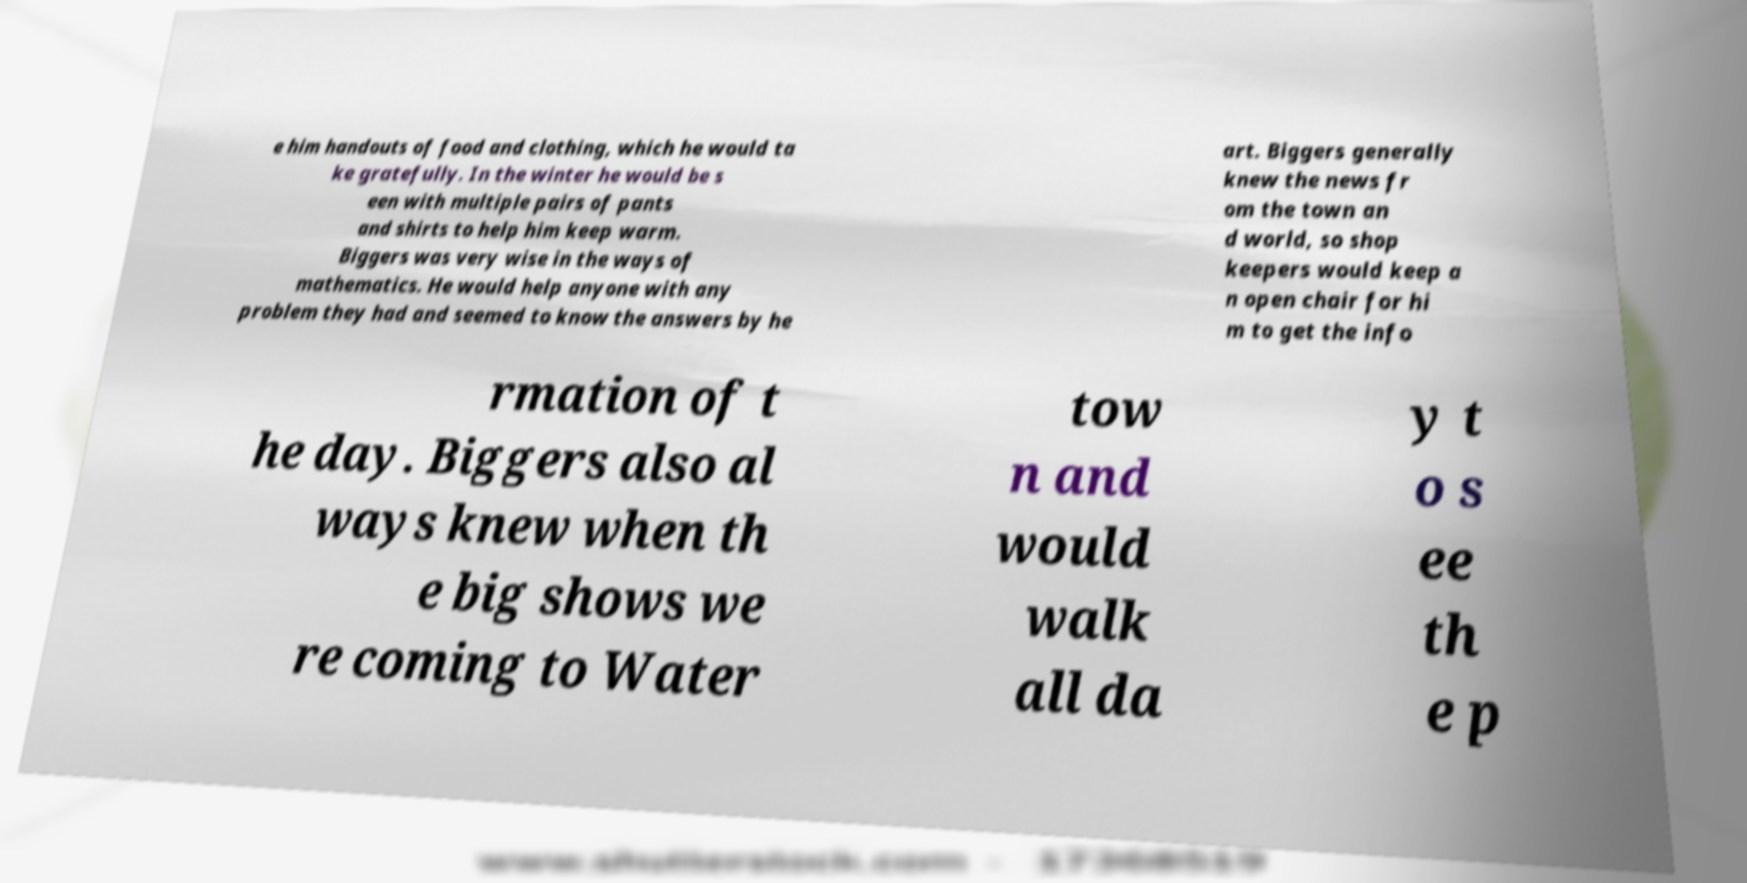Please read and relay the text visible in this image. What does it say? e him handouts of food and clothing, which he would ta ke gratefully. In the winter he would be s een with multiple pairs of pants and shirts to help him keep warm. Biggers was very wise in the ways of mathematics. He would help anyone with any problem they had and seemed to know the answers by he art. Biggers generally knew the news fr om the town an d world, so shop keepers would keep a n open chair for hi m to get the info rmation of t he day. Biggers also al ways knew when th e big shows we re coming to Water tow n and would walk all da y t o s ee th e p 